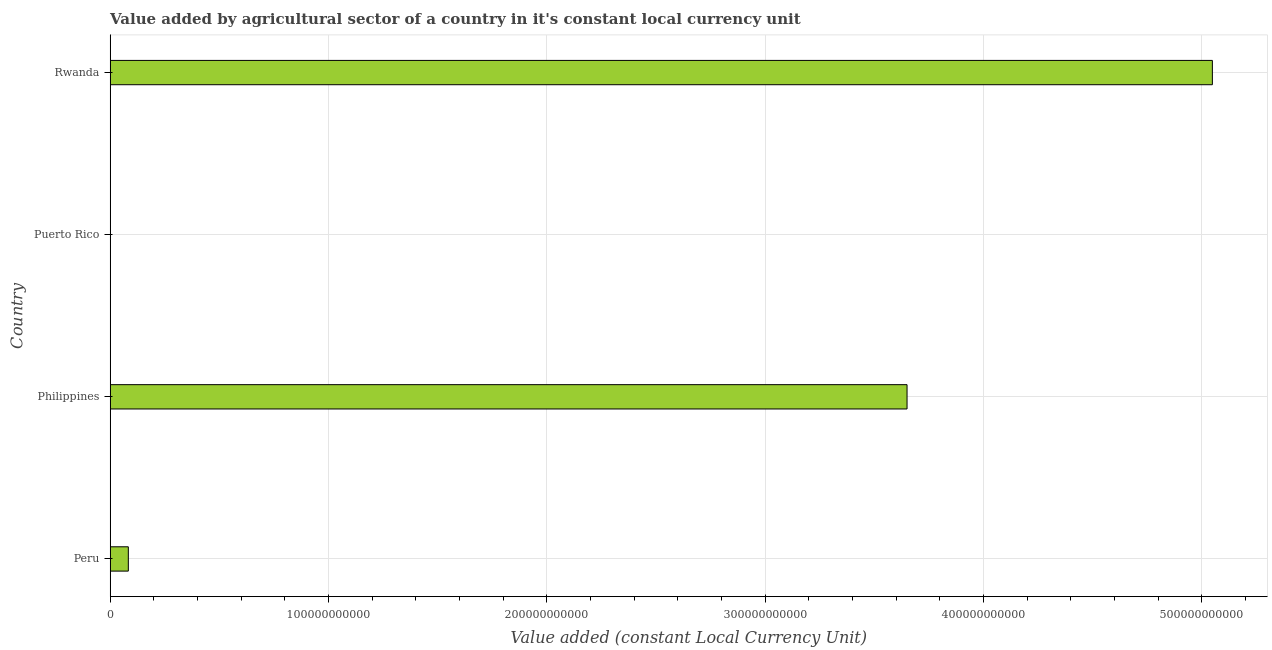Does the graph contain any zero values?
Offer a terse response. No. Does the graph contain grids?
Give a very brief answer. Yes. What is the title of the graph?
Provide a succinct answer. Value added by agricultural sector of a country in it's constant local currency unit. What is the label or title of the X-axis?
Your answer should be compact. Value added (constant Local Currency Unit). What is the label or title of the Y-axis?
Offer a terse response. Country. What is the value added by agriculture sector in Peru?
Keep it short and to the point. 8.33e+09. Across all countries, what is the maximum value added by agriculture sector?
Offer a very short reply. 5.05e+11. Across all countries, what is the minimum value added by agriculture sector?
Your response must be concise. 1.58e+08. In which country was the value added by agriculture sector maximum?
Keep it short and to the point. Rwanda. In which country was the value added by agriculture sector minimum?
Your response must be concise. Puerto Rico. What is the sum of the value added by agriculture sector?
Offer a terse response. 8.78e+11. What is the difference between the value added by agriculture sector in Peru and Puerto Rico?
Offer a terse response. 8.17e+09. What is the average value added by agriculture sector per country?
Offer a terse response. 2.20e+11. What is the median value added by agriculture sector?
Your answer should be compact. 1.87e+11. In how many countries, is the value added by agriculture sector greater than 500000000000 LCU?
Offer a very short reply. 1. What is the ratio of the value added by agriculture sector in Philippines to that in Puerto Rico?
Make the answer very short. 2307.63. What is the difference between the highest and the second highest value added by agriculture sector?
Ensure brevity in your answer.  1.40e+11. What is the difference between the highest and the lowest value added by agriculture sector?
Offer a terse response. 5.05e+11. How many bars are there?
Your answer should be compact. 4. How many countries are there in the graph?
Your response must be concise. 4. What is the difference between two consecutive major ticks on the X-axis?
Keep it short and to the point. 1.00e+11. Are the values on the major ticks of X-axis written in scientific E-notation?
Make the answer very short. No. What is the Value added (constant Local Currency Unit) of Peru?
Ensure brevity in your answer.  8.33e+09. What is the Value added (constant Local Currency Unit) in Philippines?
Give a very brief answer. 3.65e+11. What is the Value added (constant Local Currency Unit) of Puerto Rico?
Provide a succinct answer. 1.58e+08. What is the Value added (constant Local Currency Unit) in Rwanda?
Provide a succinct answer. 5.05e+11. What is the difference between the Value added (constant Local Currency Unit) in Peru and Philippines?
Your answer should be very brief. -3.57e+11. What is the difference between the Value added (constant Local Currency Unit) in Peru and Puerto Rico?
Offer a very short reply. 8.17e+09. What is the difference between the Value added (constant Local Currency Unit) in Peru and Rwanda?
Provide a succinct answer. -4.97e+11. What is the difference between the Value added (constant Local Currency Unit) in Philippines and Puerto Rico?
Your response must be concise. 3.65e+11. What is the difference between the Value added (constant Local Currency Unit) in Philippines and Rwanda?
Provide a succinct answer. -1.40e+11. What is the difference between the Value added (constant Local Currency Unit) in Puerto Rico and Rwanda?
Make the answer very short. -5.05e+11. What is the ratio of the Value added (constant Local Currency Unit) in Peru to that in Philippines?
Provide a short and direct response. 0.02. What is the ratio of the Value added (constant Local Currency Unit) in Peru to that in Puerto Rico?
Make the answer very short. 52.66. What is the ratio of the Value added (constant Local Currency Unit) in Peru to that in Rwanda?
Give a very brief answer. 0.02. What is the ratio of the Value added (constant Local Currency Unit) in Philippines to that in Puerto Rico?
Ensure brevity in your answer.  2307.63. What is the ratio of the Value added (constant Local Currency Unit) in Philippines to that in Rwanda?
Make the answer very short. 0.72. What is the ratio of the Value added (constant Local Currency Unit) in Puerto Rico to that in Rwanda?
Your response must be concise. 0. 